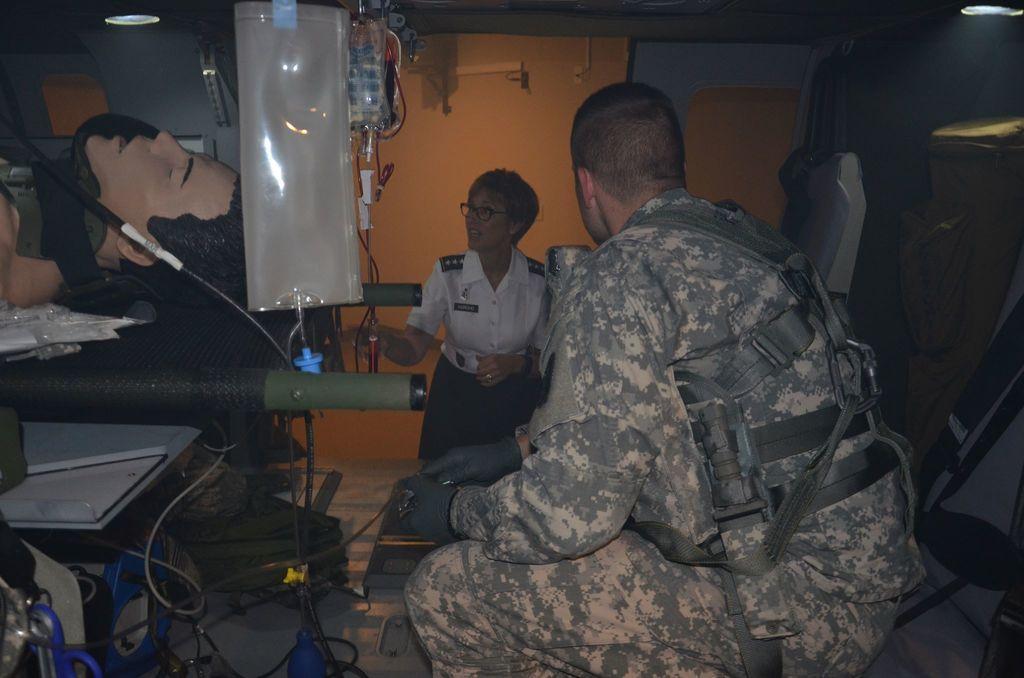Could you give a brief overview of what you see in this image? In this image we can see a man is sitting. He is wearing an army uniform. In the background of the image, we can see a woman. On the left side of the image, we can see a stretcher, wire, dummy body of a person, lights and plastic containers. We can see a wall in the background of the image. 